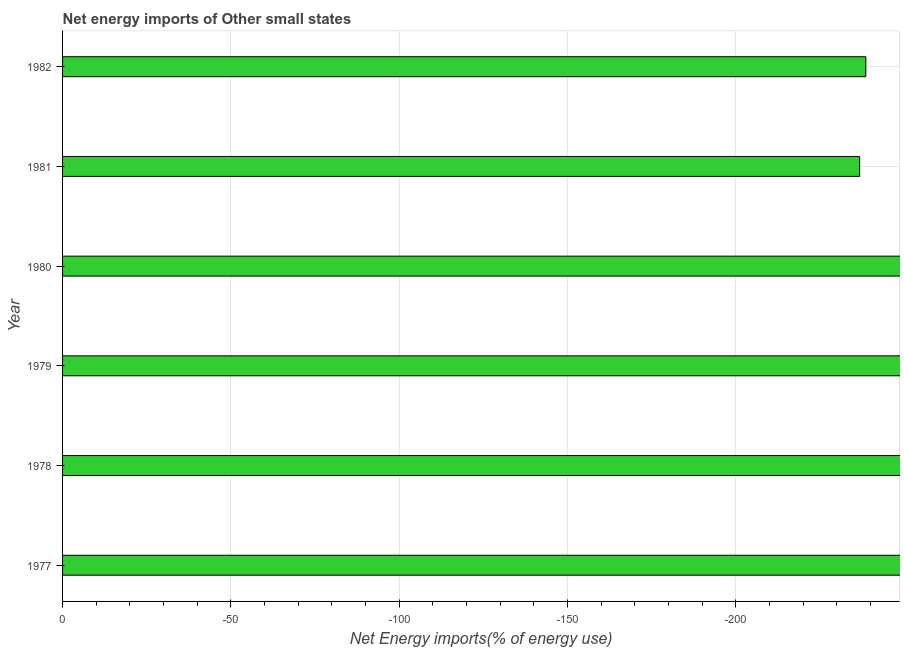Does the graph contain grids?
Offer a very short reply. Yes. What is the title of the graph?
Offer a very short reply. Net energy imports of Other small states. What is the label or title of the X-axis?
Your response must be concise. Net Energy imports(% of energy use). What is the label or title of the Y-axis?
Your answer should be compact. Year. What is the energy imports in 1980?
Provide a short and direct response. 0. Across all years, what is the minimum energy imports?
Keep it short and to the point. 0. What is the average energy imports per year?
Provide a short and direct response. 0. What is the median energy imports?
Make the answer very short. 0. In how many years, is the energy imports greater than -230 %?
Your response must be concise. 0. In how many years, is the energy imports greater than the average energy imports taken over all years?
Provide a short and direct response. 0. How many bars are there?
Offer a terse response. 0. What is the Net Energy imports(% of energy use) in 1978?
Offer a very short reply. 0. What is the Net Energy imports(% of energy use) of 1979?
Make the answer very short. 0. What is the Net Energy imports(% of energy use) of 1982?
Provide a succinct answer. 0. 